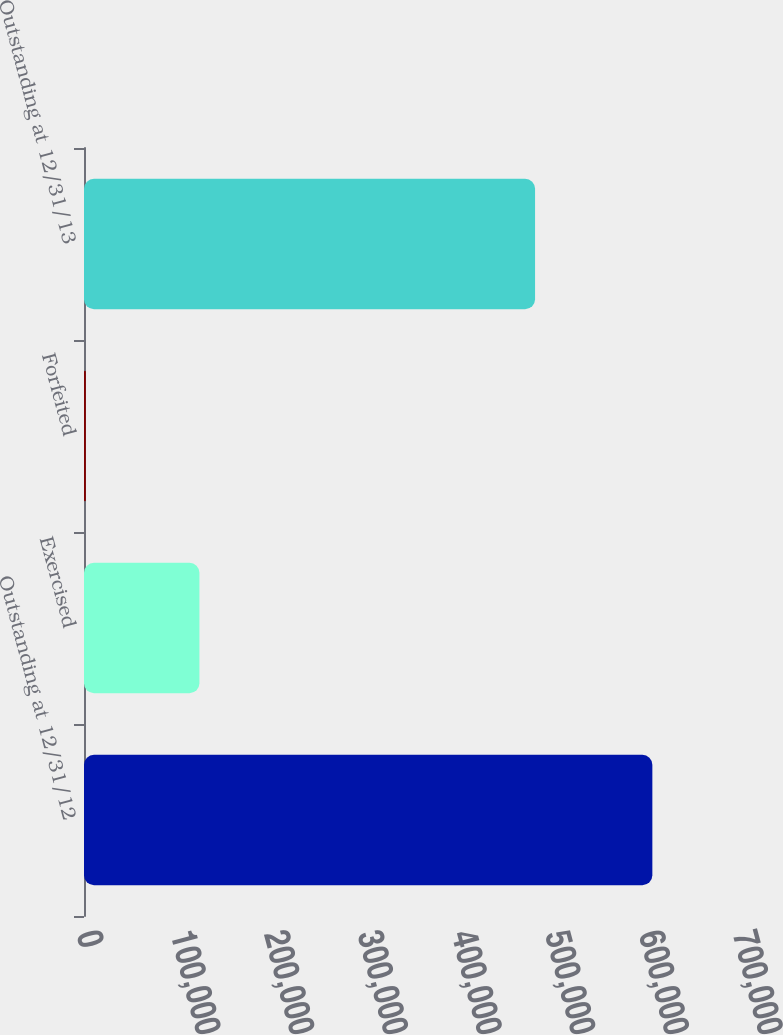Convert chart to OTSL. <chart><loc_0><loc_0><loc_500><loc_500><bar_chart><fcel>Outstanding at 12/31/12<fcel>Exercised<fcel>Forfeited<fcel>Outstanding at 12/31/13<nl><fcel>606475<fcel>123165<fcel>2000<fcel>481310<nl></chart> 